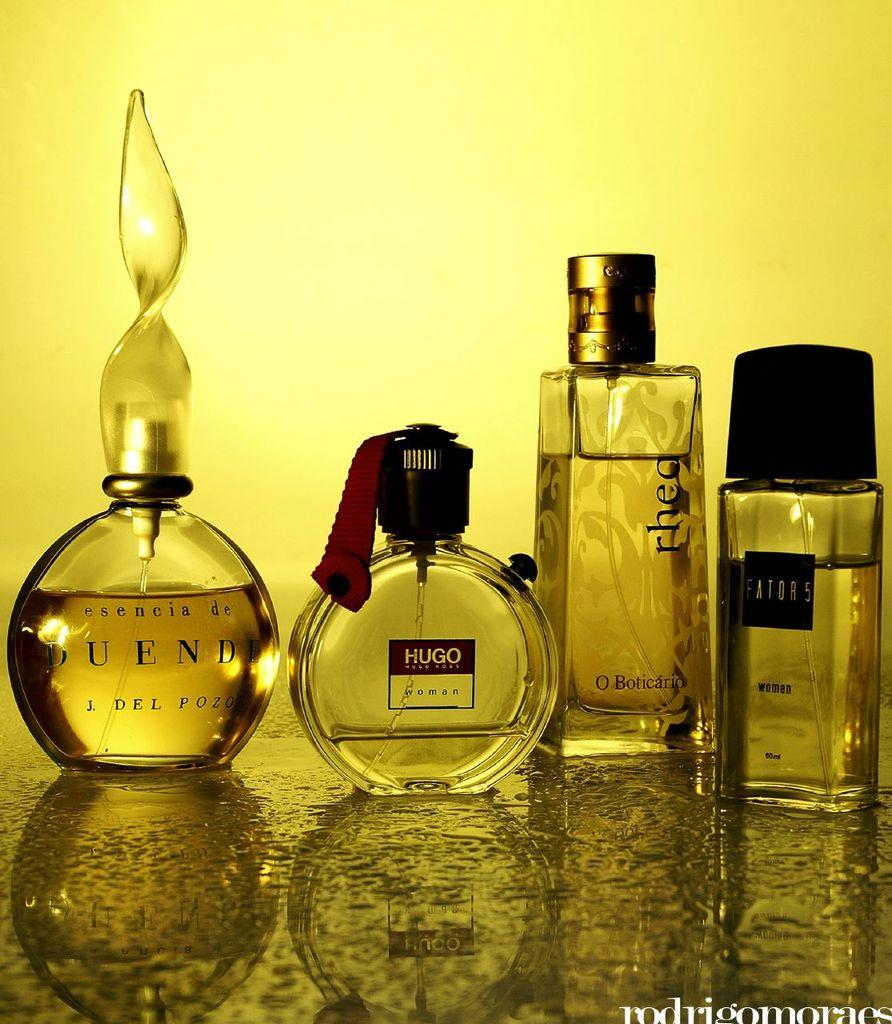<image>
Write a terse but informative summary of the picture. A variety of colognes including a bottle of Hugo. 